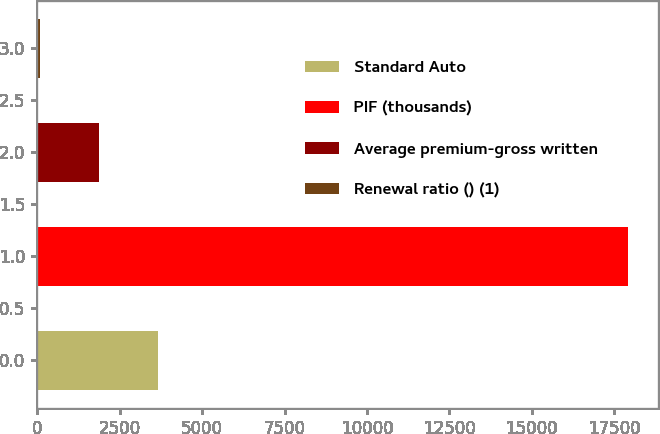Convert chart. <chart><loc_0><loc_0><loc_500><loc_500><bar_chart><fcel>Standard Auto<fcel>PIF (thousands)<fcel>Average premium-gross written<fcel>Renewal ratio () (1)<nl><fcel>3655.92<fcel>17924<fcel>1872.41<fcel>88.9<nl></chart> 